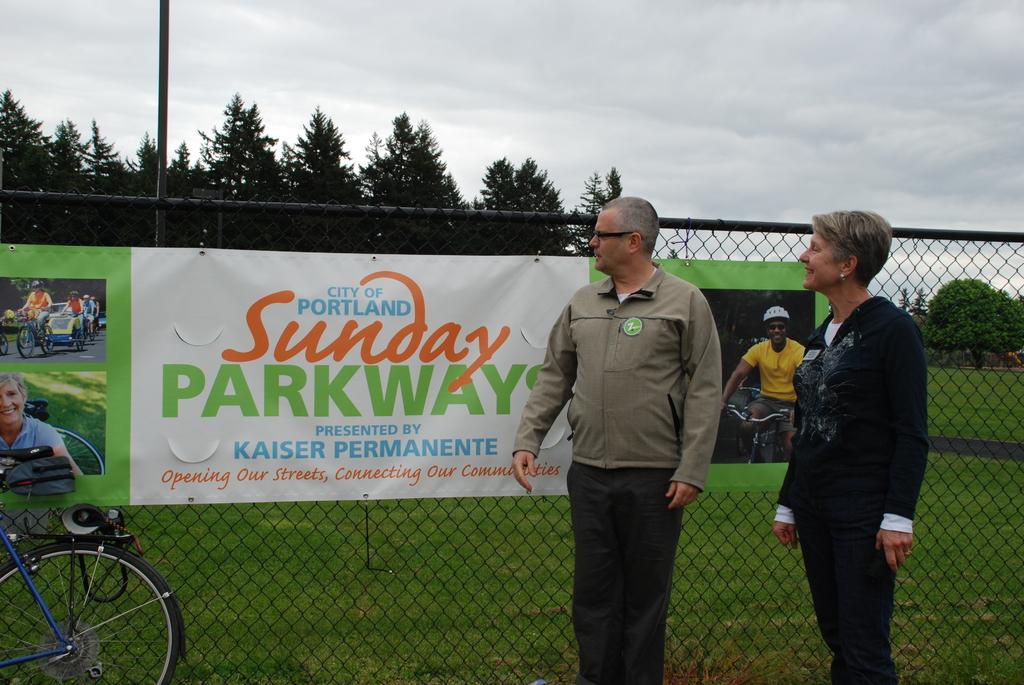Can you describe this image briefly? In this image i can see a man and a woman standing in front of a banner. I can see a vehicle and a fence. In the background i can see the sky and few trees. 